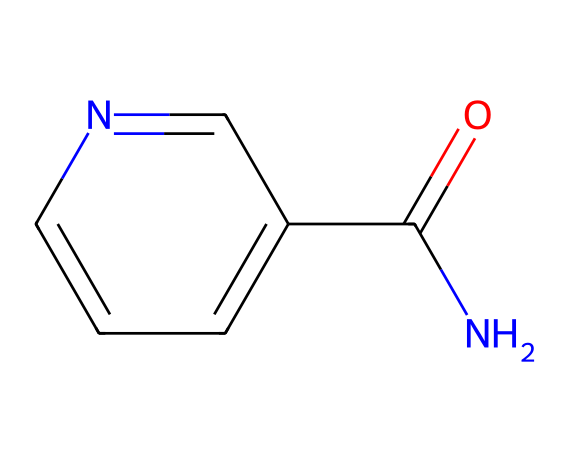What is the name of this chemical? The structure shown corresponds to niacinamide, which is a derivative of vitamin B3. This can be identified by recognizing the functional groups and the core structure common to niacinamide.
Answer: niacinamide How many carbon atoms are present in niacinamide? From the SMILES representation, we can count the number of carbon atoms. There are 6 carbon atoms in total: one in the amide group and five in the aromatic ring.
Answer: 6 What functional group is present in niacinamide? The presence of the nitrogen atom bonded to a carbonyl group and adjacent to an aromatic ring indicates that niacinamide contains an amide functional group.
Answer: amide What type of bond connects the carbonyl carbon to the nitrogen? The bond between the carbonyl carbon and the nitrogen is a single covalent bond. This is evidenced by the structure where the nitrogen atom is directly attached to the carbon of the carbonyl group.
Answer: single bond What is the primary role of niacinamide in cosmetics? Niacinamide is primarily used for its anti-aging properties, particularly in improving skin elasticity and reducing the appearance of fine lines and wrinkles.
Answer: anti-aging How does the molecular structure of niacinamide contribute to its bioactivity? The presence of both the nitrogen in the amide group and the aromatic ring allows for interactions with skin receptors and enhances its absorption, contributing to its bioactivity. The molecular structure facilitates its utility in skin care formulations.
Answer: enhances absorption 